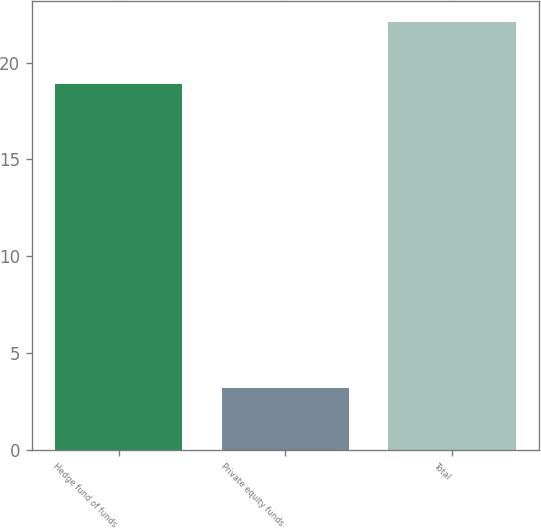Convert chart to OTSL. <chart><loc_0><loc_0><loc_500><loc_500><bar_chart><fcel>Hedge fund of funds<fcel>Private equity funds<fcel>Total<nl><fcel>18.9<fcel>3.2<fcel>22.1<nl></chart> 